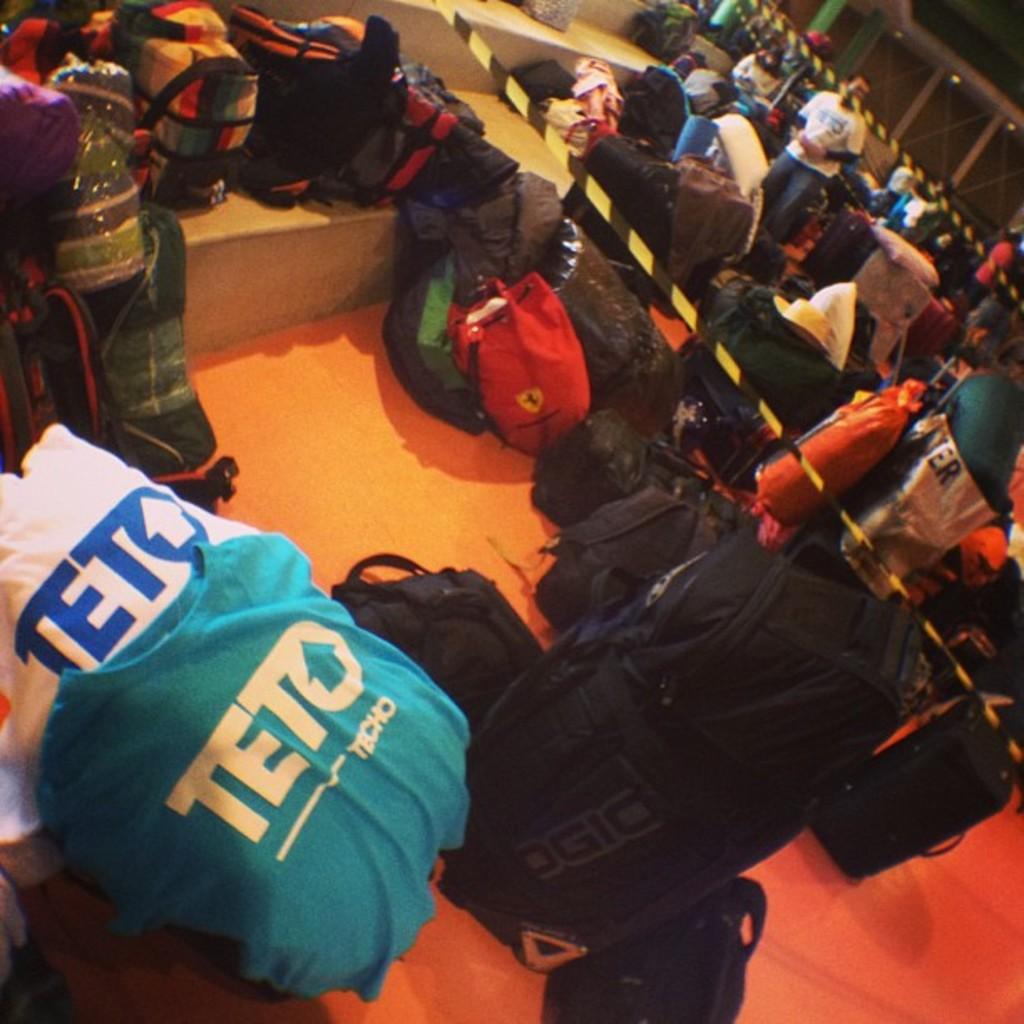What is the brand of the gear at the bottom left?
Provide a short and direct response. Teto. What brand is the black bag on the bottom right?
Your response must be concise. Ogio. 